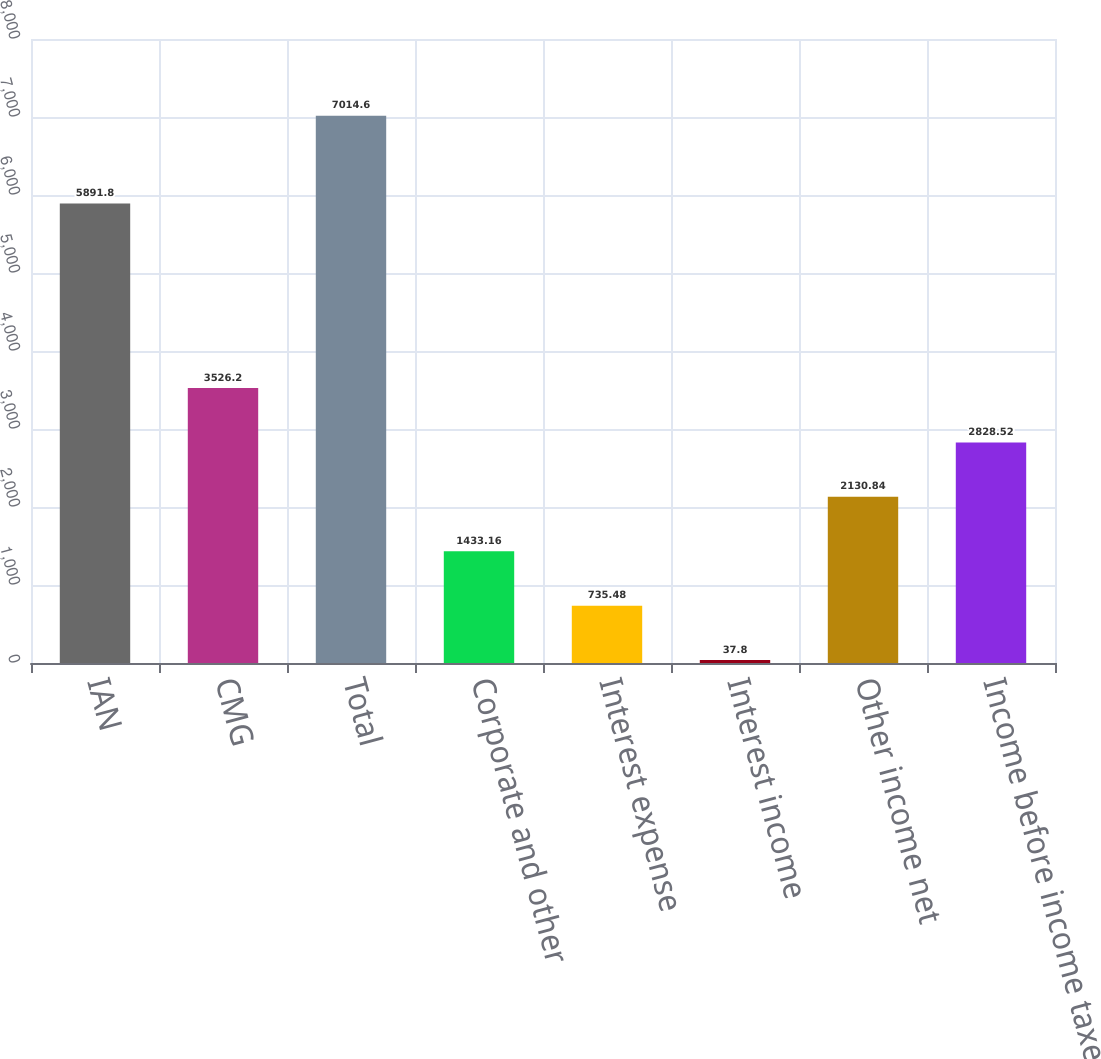Convert chart. <chart><loc_0><loc_0><loc_500><loc_500><bar_chart><fcel>IAN<fcel>CMG<fcel>Total<fcel>Corporate and other<fcel>Interest expense<fcel>Interest income<fcel>Other income net<fcel>Income before income taxes<nl><fcel>5891.8<fcel>3526.2<fcel>7014.6<fcel>1433.16<fcel>735.48<fcel>37.8<fcel>2130.84<fcel>2828.52<nl></chart> 